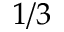Convert formula to latex. <formula><loc_0><loc_0><loc_500><loc_500>1 / 3</formula> 